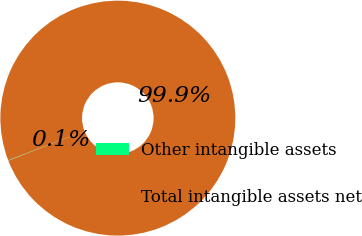Convert chart. <chart><loc_0><loc_0><loc_500><loc_500><pie_chart><fcel>Other intangible assets<fcel>Total intangible assets net<nl><fcel>0.07%<fcel>99.93%<nl></chart> 